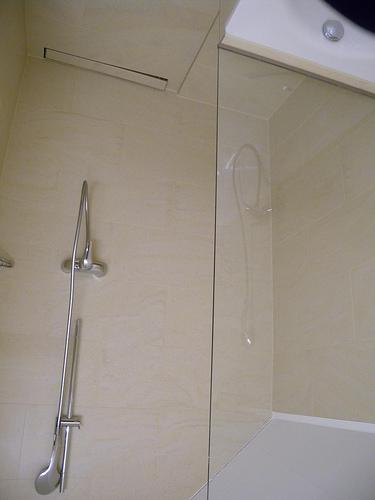Question: why would you use this?
Choices:
A. To brush your teeth.
B. To clean the toilet.
C. To talk or text.
D. To clean yourself.
Answer with the letter. Answer: D Question: what color is the shower?
Choices:
A. White.
B. Silver.
C. Beige.
D. Black.
Answer with the letter. Answer: C Question: where is this located?
Choices:
A. Bedroom.
B. Livingroom.
C. Kitchen.
D. In the bathroom.
Answer with the letter. Answer: D Question: when was this picture taken?
Choices:
A. While the water was off.
B. After it snowed.
C. After it rained.
D. Before bedtime.
Answer with the letter. Answer: A 